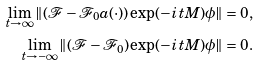Convert formula to latex. <formula><loc_0><loc_0><loc_500><loc_500>\lim _ { t \to \infty } \| ( { \mathcal { F } } - { \mathcal { F } } _ { 0 } a ( \cdot ) ) \exp ( - i t M ) \phi \| = 0 , \\ \lim _ { t \to - \infty } \| ( { \mathcal { F } } - { \mathcal { F } } _ { 0 } ) \exp ( - i t M ) \phi \| = 0 .</formula> 